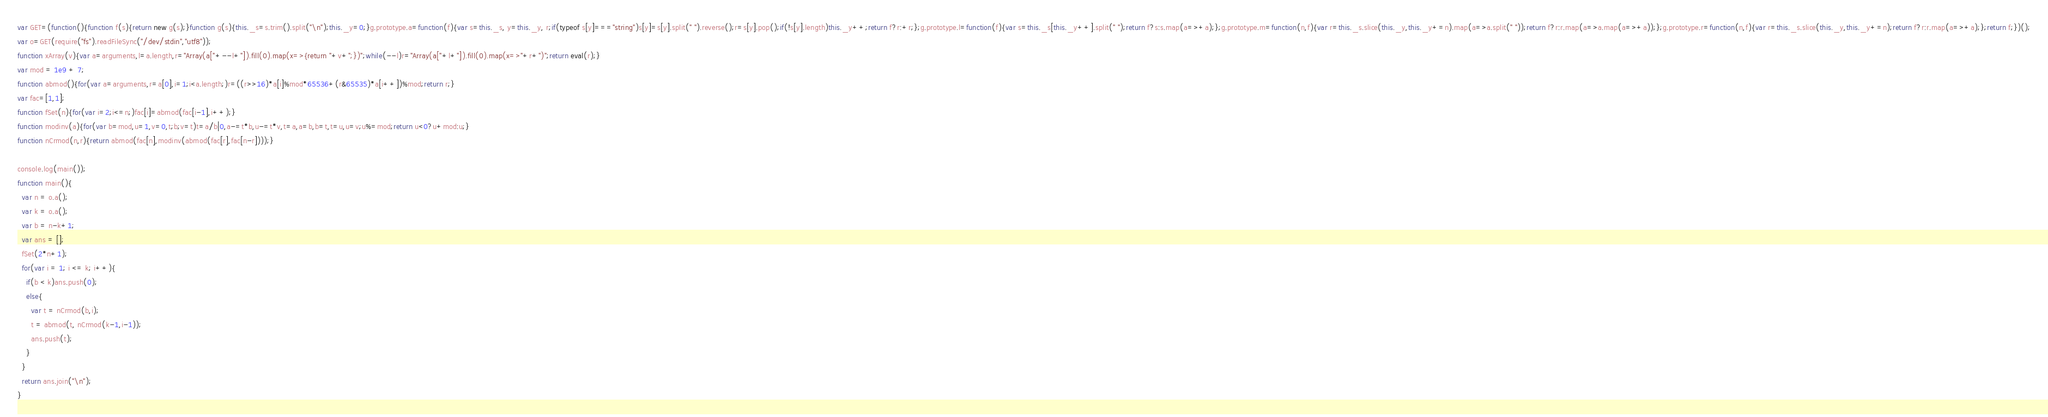Convert code to text. <code><loc_0><loc_0><loc_500><loc_500><_JavaScript_>var GET=(function(){function f(s){return new g(s);}function g(s){this._s=s.trim().split("\n");this._y=0;}g.prototype.a=function(f){var s=this._s, y=this._y, r;if(typeof s[y]==="string")s[y]=s[y].split(" ").reverse();r=s[y].pop();if(!s[y].length)this._y++;return f?r:+r;};g.prototype.l=function(f){var s=this._s[this._y++].split(" ");return f?s:s.map(a=>+a);};g.prototype.m=function(n,f){var r=this._s.slice(this._y,this._y+=n).map(a=>a.split(" "));return f?r:r.map(a=>a.map(a=>+a));};g.prototype.r=function(n,f){var r=this._s.slice(this._y,this._y+=n);return f?r:r.map(a=>+a);};return f;})();
var o=GET(require("fs").readFileSync("/dev/stdin","utf8"));
function xArray(v){var a=arguments,l=a.length,r="Array(a["+--l+"]).fill(0).map(x=>{return "+v+";})";while(--l)r="Array(a["+l+"]).fill(0).map(x=>"+r+")";return eval(r);}
var mod = 1e9 + 7;
function abmod(){for(var a=arguments,r=a[0],i=1;i<a.length;)r=((r>>16)*a[i]%mod*65536+(r&65535)*a[i++])%mod;return r;}
var fac=[1,1];
function fSet(n){for(var i=2;i<=n;)fac[i]=abmod(fac[i-1],i++);}
function modinv(a){for(var b=mod,u=1,v=0,t;b;v=t)t=a/b|0,a-=t*b,u-=t*v,t=a,a=b,b=t,t=u,u=v;u%=mod;return u<0?u+mod:u;}
function nCrmod(n,r){return abmod(fac[n],modinv(abmod(fac[r],fac[n-r])));}

console.log(main());
function main(){
  var n = o.a();
  var k = o.a();
  var b = n-k+1;
  var ans = [];
  fSet(2*n+1);
  for(var i = 1; i <= k; i++){
    if(b < k)ans.push(0);
    else{
      var t = nCrmod(b,i);
      t = abmod(t, nCrmod(k-1,i-1));
      ans.push(t);
    }
  }
  return ans.join("\n");
}</code> 